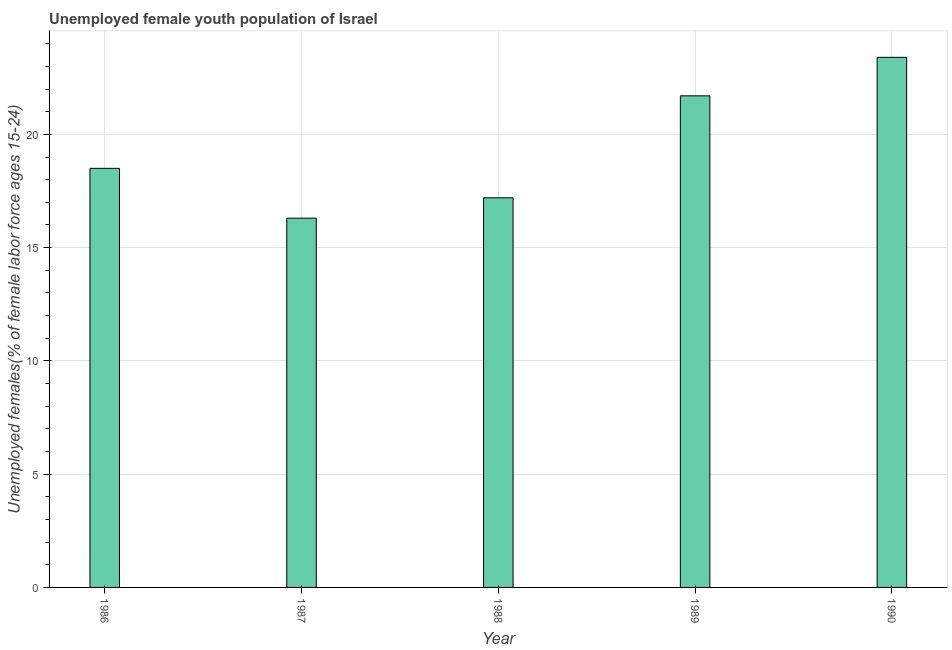What is the title of the graph?
Keep it short and to the point. Unemployed female youth population of Israel. What is the label or title of the Y-axis?
Provide a short and direct response. Unemployed females(% of female labor force ages 15-24). What is the unemployed female youth in 1987?
Make the answer very short. 16.3. Across all years, what is the maximum unemployed female youth?
Provide a succinct answer. 23.4. Across all years, what is the minimum unemployed female youth?
Provide a short and direct response. 16.3. What is the sum of the unemployed female youth?
Provide a succinct answer. 97.1. What is the average unemployed female youth per year?
Give a very brief answer. 19.42. What is the median unemployed female youth?
Your response must be concise. 18.5. What is the ratio of the unemployed female youth in 1987 to that in 1990?
Make the answer very short. 0.7. What is the difference between the highest and the second highest unemployed female youth?
Offer a very short reply. 1.7. Is the sum of the unemployed female youth in 1987 and 1988 greater than the maximum unemployed female youth across all years?
Provide a short and direct response. Yes. What is the difference between the highest and the lowest unemployed female youth?
Provide a short and direct response. 7.1. Are all the bars in the graph horizontal?
Make the answer very short. No. What is the Unemployed females(% of female labor force ages 15-24) of 1986?
Provide a short and direct response. 18.5. What is the Unemployed females(% of female labor force ages 15-24) of 1987?
Your answer should be compact. 16.3. What is the Unemployed females(% of female labor force ages 15-24) of 1988?
Give a very brief answer. 17.2. What is the Unemployed females(% of female labor force ages 15-24) of 1989?
Ensure brevity in your answer.  21.7. What is the Unemployed females(% of female labor force ages 15-24) of 1990?
Provide a succinct answer. 23.4. What is the difference between the Unemployed females(% of female labor force ages 15-24) in 1986 and 1987?
Provide a succinct answer. 2.2. What is the difference between the Unemployed females(% of female labor force ages 15-24) in 1986 and 1990?
Offer a very short reply. -4.9. What is the difference between the Unemployed females(% of female labor force ages 15-24) in 1987 and 1988?
Offer a terse response. -0.9. What is the difference between the Unemployed females(% of female labor force ages 15-24) in 1987 and 1989?
Your answer should be compact. -5.4. What is the difference between the Unemployed females(% of female labor force ages 15-24) in 1988 and 1989?
Provide a succinct answer. -4.5. What is the ratio of the Unemployed females(% of female labor force ages 15-24) in 1986 to that in 1987?
Make the answer very short. 1.14. What is the ratio of the Unemployed females(% of female labor force ages 15-24) in 1986 to that in 1988?
Provide a short and direct response. 1.08. What is the ratio of the Unemployed females(% of female labor force ages 15-24) in 1986 to that in 1989?
Your answer should be compact. 0.85. What is the ratio of the Unemployed females(% of female labor force ages 15-24) in 1986 to that in 1990?
Offer a very short reply. 0.79. What is the ratio of the Unemployed females(% of female labor force ages 15-24) in 1987 to that in 1988?
Your answer should be very brief. 0.95. What is the ratio of the Unemployed females(% of female labor force ages 15-24) in 1987 to that in 1989?
Your answer should be compact. 0.75. What is the ratio of the Unemployed females(% of female labor force ages 15-24) in 1987 to that in 1990?
Keep it short and to the point. 0.7. What is the ratio of the Unemployed females(% of female labor force ages 15-24) in 1988 to that in 1989?
Your response must be concise. 0.79. What is the ratio of the Unemployed females(% of female labor force ages 15-24) in 1988 to that in 1990?
Offer a terse response. 0.73. What is the ratio of the Unemployed females(% of female labor force ages 15-24) in 1989 to that in 1990?
Offer a terse response. 0.93. 